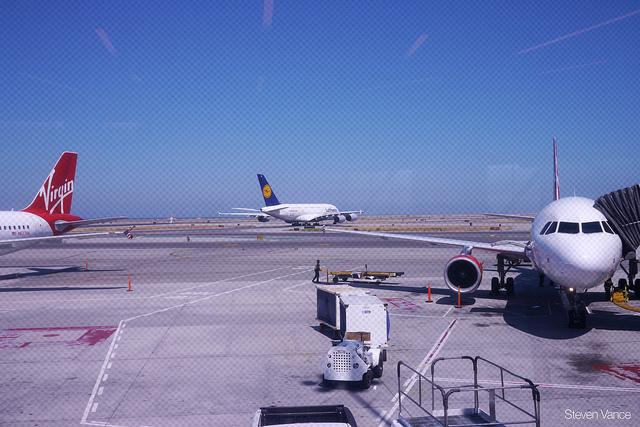Who owns the vehicle on the left?

Choices:
A) lufthansa
B) delta
C) virgin atlantic
D) united airlines virgin atlantic 